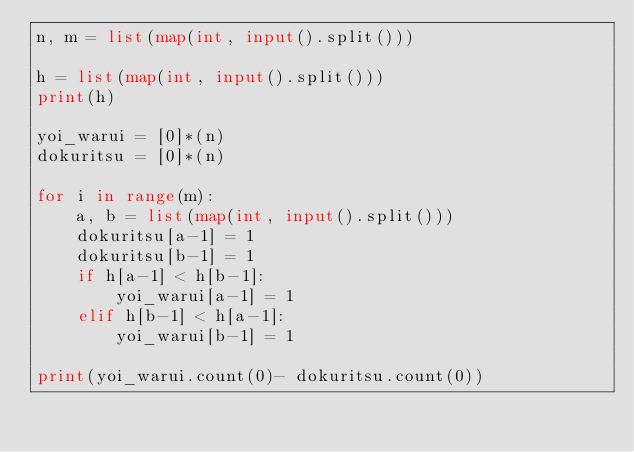Convert code to text. <code><loc_0><loc_0><loc_500><loc_500><_Python_>n, m = list(map(int, input().split()))

h = list(map(int, input().split()))
print(h)

yoi_warui = [0]*(n)
dokuritsu = [0]*(n)

for i in range(m):
    a, b = list(map(int, input().split()))
    dokuritsu[a-1] = 1
    dokuritsu[b-1] = 1
    if h[a-1] < h[b-1]:
        yoi_warui[a-1] = 1
    elif h[b-1] < h[a-1]:
        yoi_warui[b-1] = 1

print(yoi_warui.count(0)- dokuritsu.count(0))
</code> 